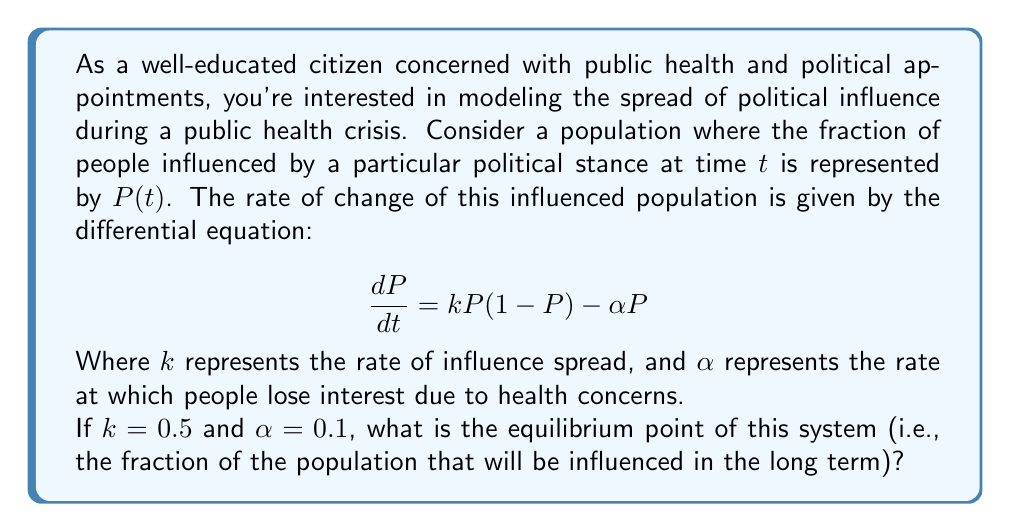Help me with this question. To solve this problem, we'll follow these steps:

1) The equilibrium point occurs when $\frac{dP}{dt} = 0$. So, we set the equation equal to zero:

   $$0 = kP(1-P) - \alpha P$$

2) Substitute the given values $k = 0.5$ and $\alpha = 0.1$:

   $$0 = 0.5P(1-P) - 0.1P$$

3) Expand the equation:

   $$0 = 0.5P - 0.5P^2 - 0.1P$$

4) Combine like terms:

   $$0 = 0.4P - 0.5P^2$$

5) Factor out $P$:

   $$0 = P(0.4 - 0.5P)$$

6) This equation is satisfied when either $P = 0$ or $0.4 - 0.5P = 0$. We're interested in the non-zero solution, so:

   $$0.4 - 0.5P = 0$$

7) Solve for $P$:

   $$0.5P = 0.4$$
   $$P = \frac{0.4}{0.5} = 0.8$$

Therefore, the equilibrium point is when 80% of the population is influenced.
Answer: $P = 0.8$ 